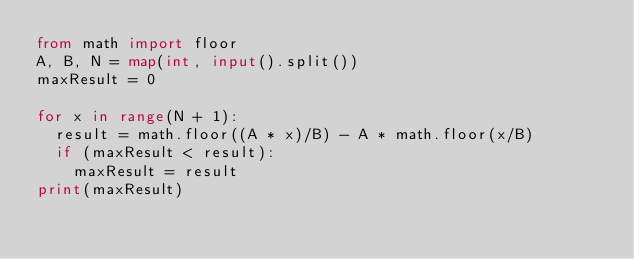<code> <loc_0><loc_0><loc_500><loc_500><_Python_>from math import floor
A, B, N = map(int, input().split())
maxResult = 0

for x in range(N + 1):
  result = math.floor((A * x)/B) - A * math.floor(x/B)
  if (maxResult < result):
    maxResult = result
print(maxResult)</code> 